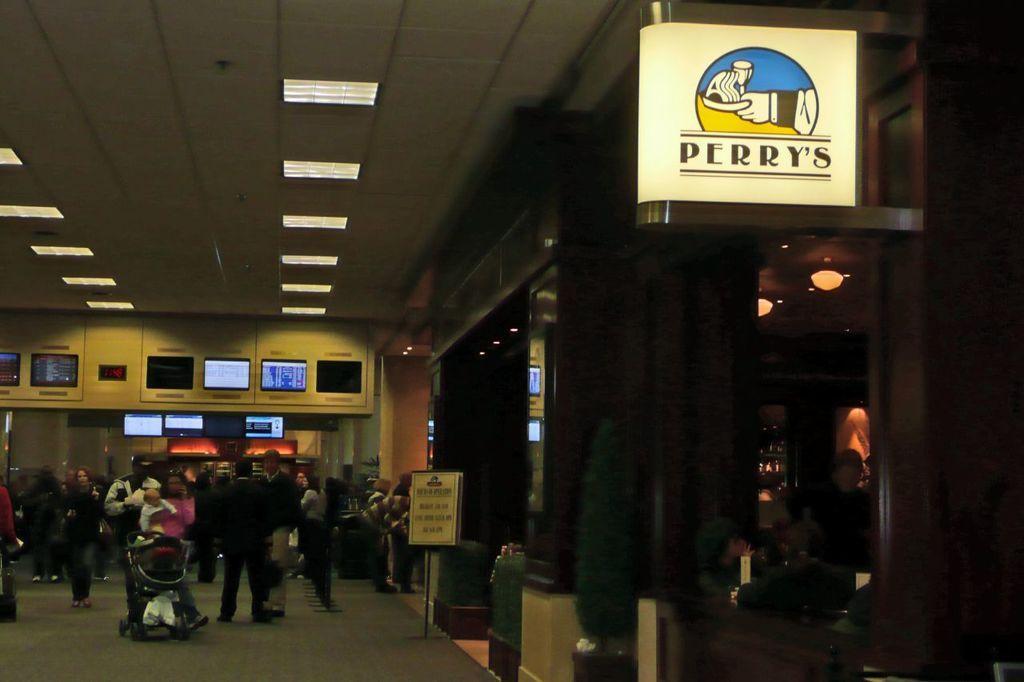In one or two sentences, can you explain what this image depicts? In this picture we can see boards and people. Lights are attached to the ceiling. Far there are screens. This person is carrying a baby. In-front of this person there is a baby chair. Floor with carpet. 